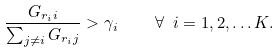Convert formula to latex. <formula><loc_0><loc_0><loc_500><loc_500>\frac { G _ { r _ { i } i } } { \sum _ { j \neq i } { G _ { r _ { i } j } } } > \gamma _ { i } \quad \forall \ i = 1 , 2 , \dots K .</formula> 